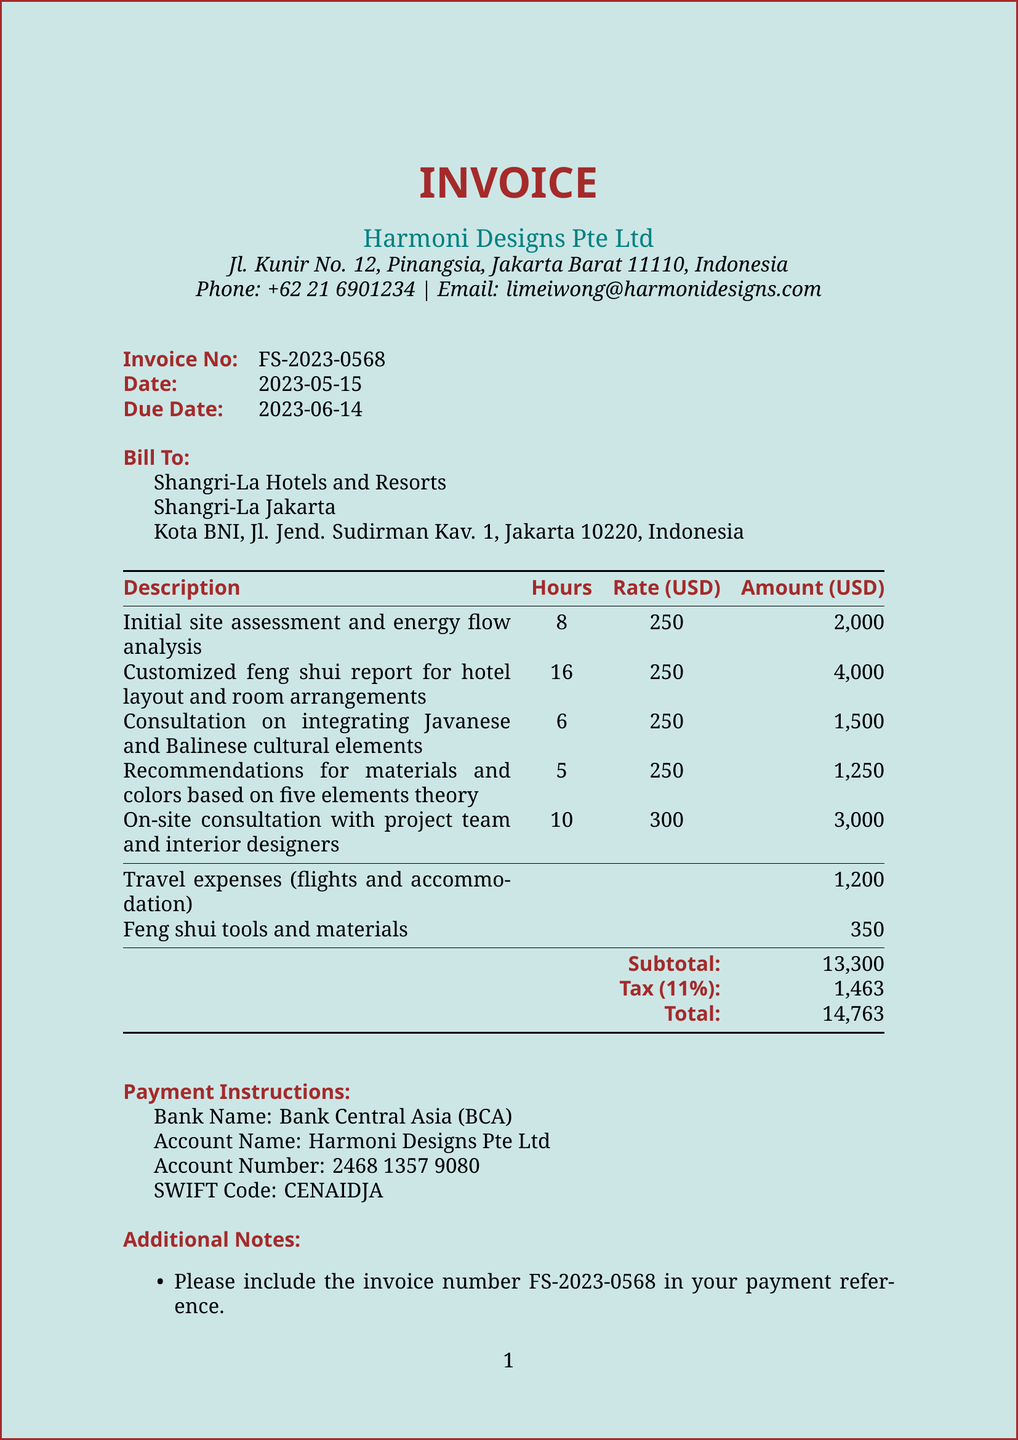What is the invoice number? The invoice number is specifically listed in the document under the invoice details section.
Answer: FS-2023-0568 Who is the client? The document provides the name of the client in the client information section.
Answer: Shangri-La Hotels and Resorts What is the due date for the invoice? The due date is stated in the invoice details section, indicating when payment is expected.
Answer: 2023-06-14 How many hours were billed for the consultation on integrating cultural elements? The hours billed for this service are found in the listed services of the document, particularly for that service.
Answer: 6 What is the total amount due? The total amount is calculated in the payment details section as the overall charge, including tax.
Answer: 14763 What is the tax rate applied? The tax rate is specified in the payment details section of the invoice.
Answer: 11% What additional charge is listed for travel expenses? The additional charges section includes specific details on travel expenses incurred.
Answer: 1200 Who should the payment be made out to? The payment instructions clarify the account name to whom payments should be addressed.
Answer: Harmoni Designs Pte Ltd What is the email for finance queries? An email address for finance-related inquiries is mentioned in the additional notes of the document.
Answer: finance@harmonidesigns.com 